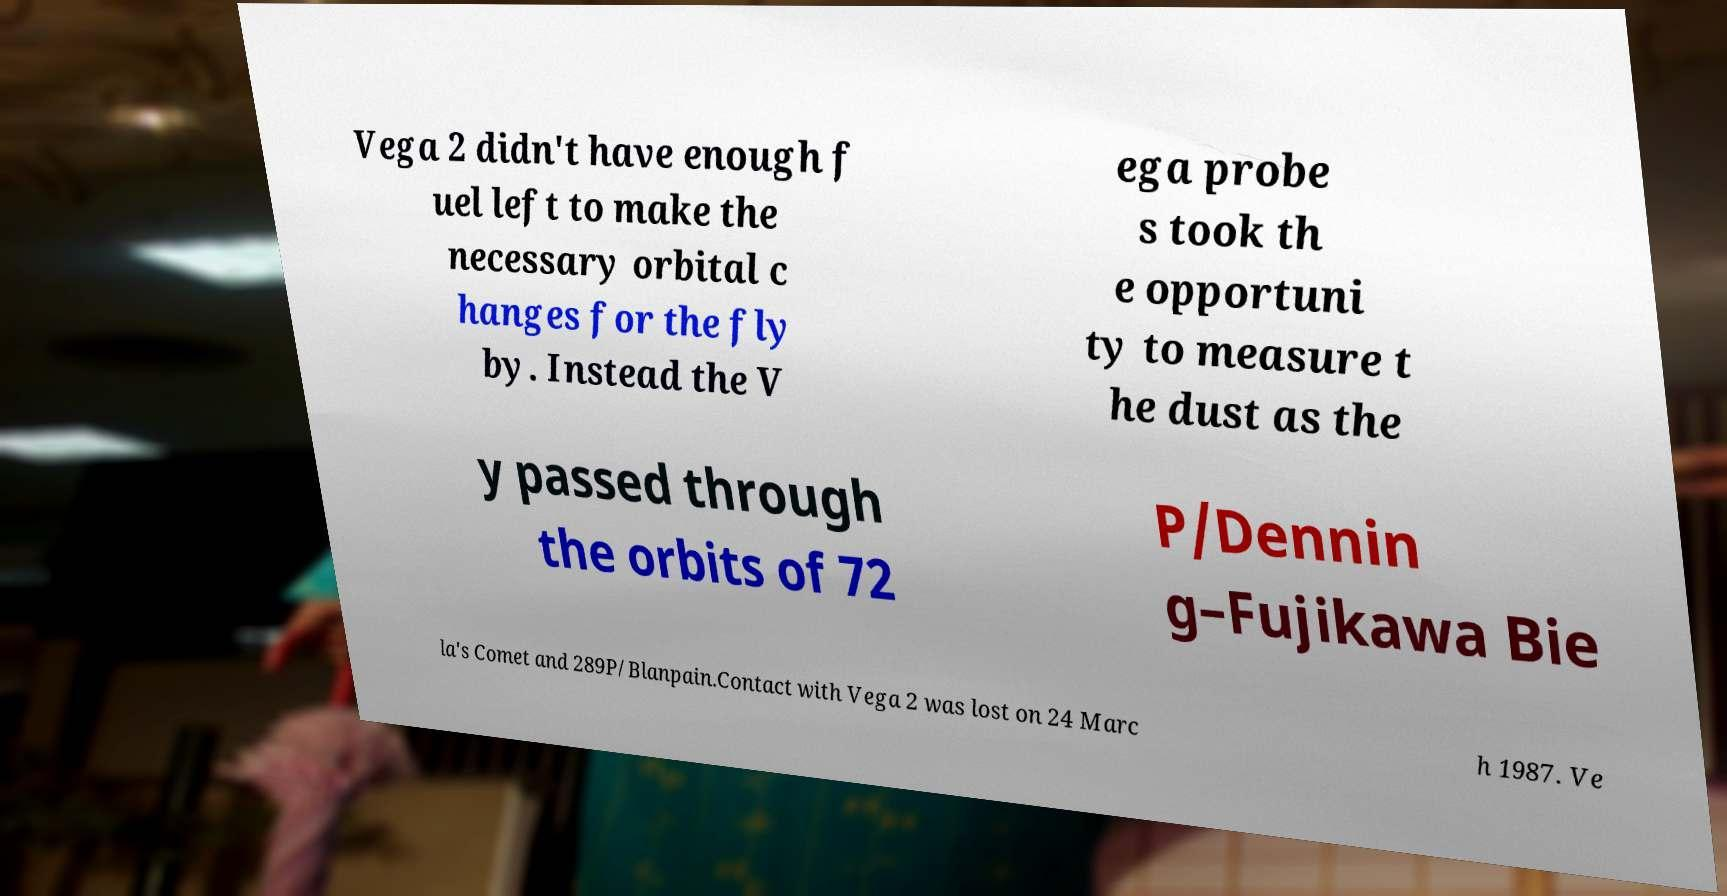For documentation purposes, I need the text within this image transcribed. Could you provide that? Vega 2 didn't have enough f uel left to make the necessary orbital c hanges for the fly by. Instead the V ega probe s took th e opportuni ty to measure t he dust as the y passed through the orbits of 72 P/Dennin g–Fujikawa Bie la's Comet and 289P/Blanpain.Contact with Vega 2 was lost on 24 Marc h 1987. Ve 